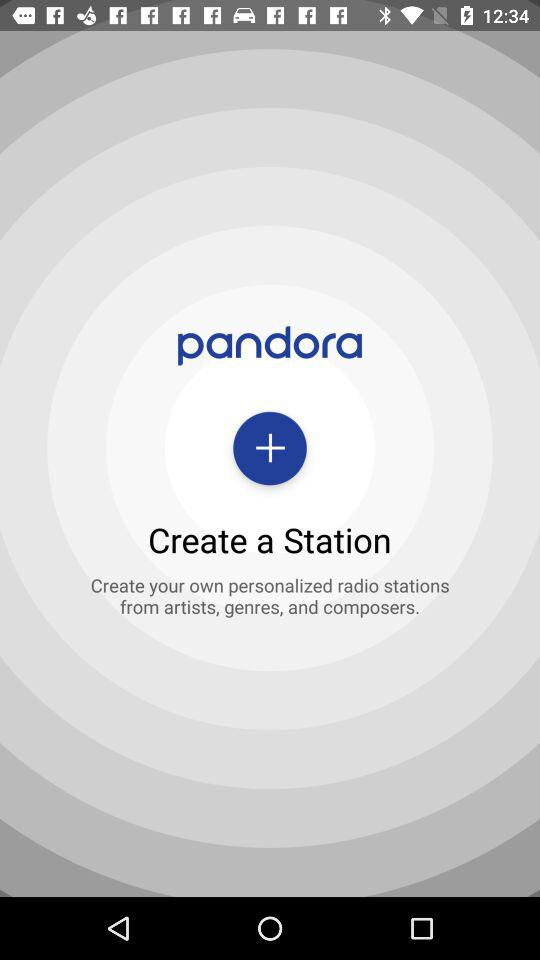What is the name of application? The name of the application is "pandora". 